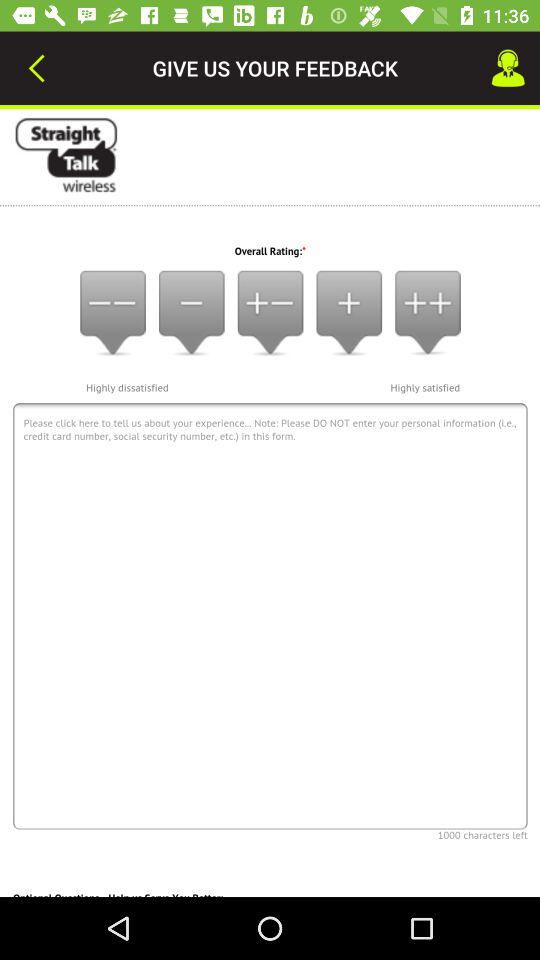How many satisfaction ratings are there?
Answer the question using a single word or phrase. 5 